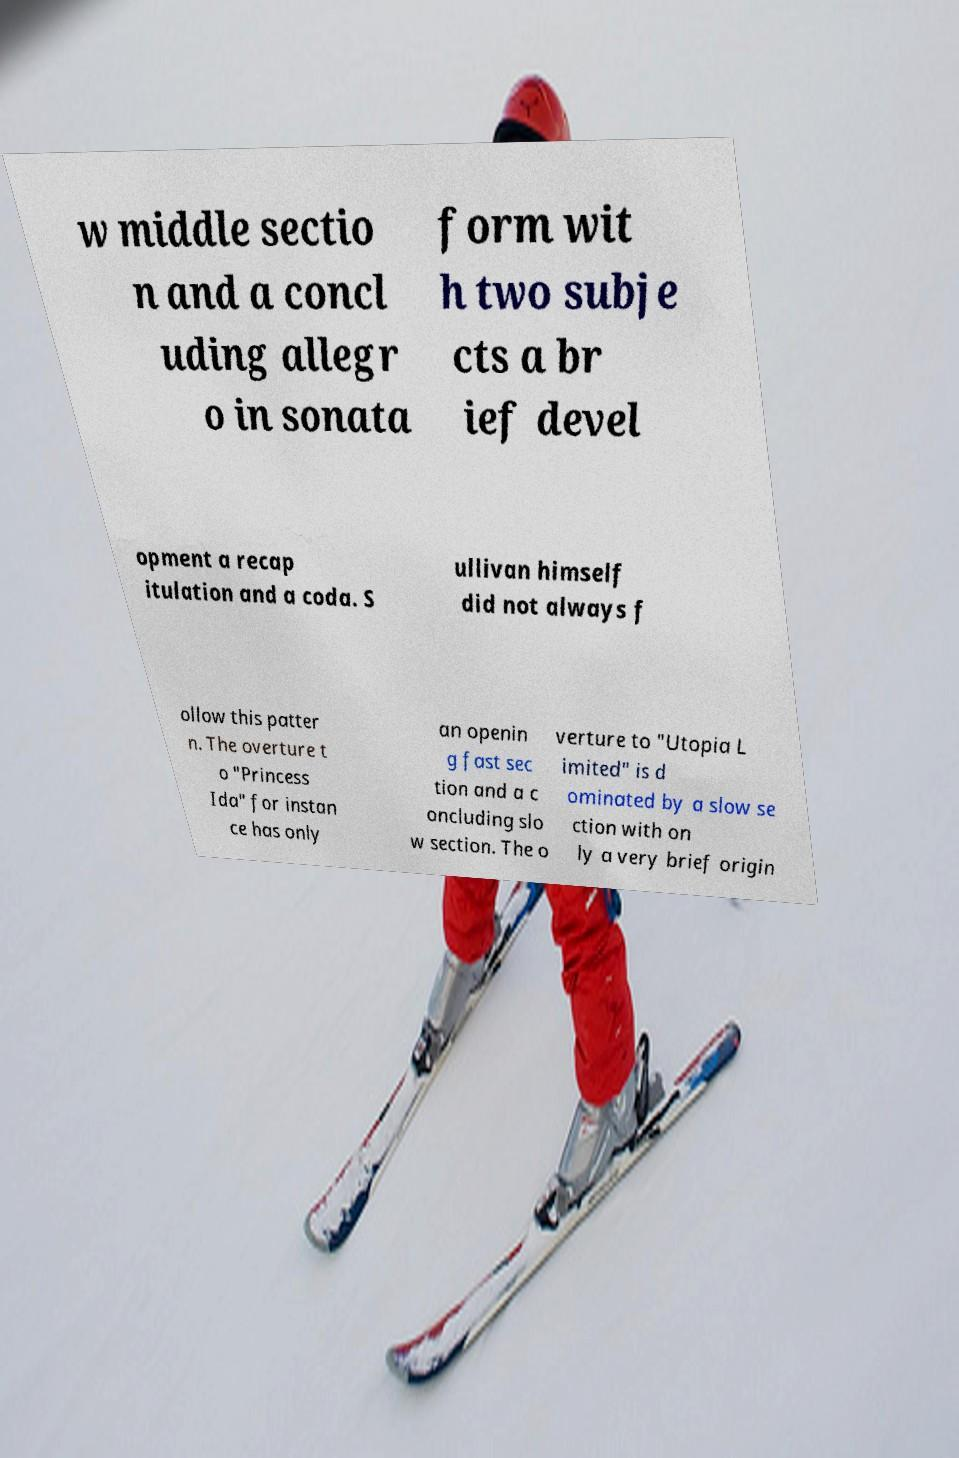There's text embedded in this image that I need extracted. Can you transcribe it verbatim? w middle sectio n and a concl uding allegr o in sonata form wit h two subje cts a br ief devel opment a recap itulation and a coda. S ullivan himself did not always f ollow this patter n. The overture t o "Princess Ida" for instan ce has only an openin g fast sec tion and a c oncluding slo w section. The o verture to "Utopia L imited" is d ominated by a slow se ction with on ly a very brief origin 